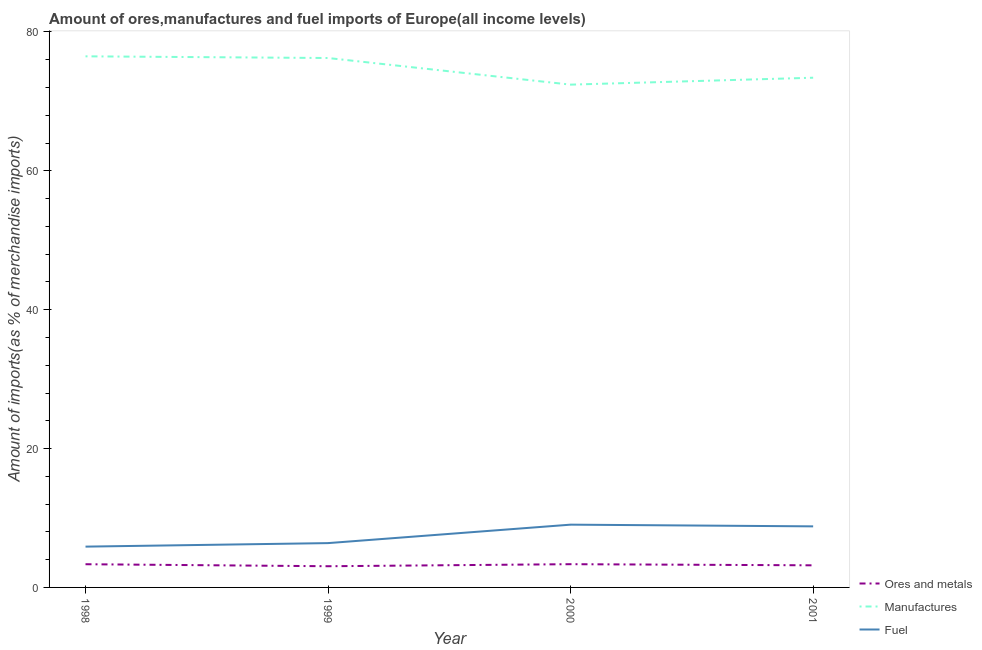How many different coloured lines are there?
Provide a short and direct response. 3. Is the number of lines equal to the number of legend labels?
Offer a very short reply. Yes. What is the percentage of fuel imports in 2000?
Your response must be concise. 9.04. Across all years, what is the maximum percentage of ores and metals imports?
Offer a very short reply. 3.35. Across all years, what is the minimum percentage of manufactures imports?
Your answer should be compact. 72.42. What is the total percentage of ores and metals imports in the graph?
Ensure brevity in your answer.  12.93. What is the difference between the percentage of manufactures imports in 1998 and that in 2001?
Offer a terse response. 3.08. What is the difference between the percentage of manufactures imports in 1999 and the percentage of fuel imports in 2001?
Offer a very short reply. 67.45. What is the average percentage of fuel imports per year?
Your answer should be very brief. 7.52. In the year 1999, what is the difference between the percentage of fuel imports and percentage of manufactures imports?
Your response must be concise. -69.87. In how many years, is the percentage of ores and metals imports greater than 44 %?
Your answer should be very brief. 0. What is the ratio of the percentage of ores and metals imports in 2000 to that in 2001?
Your answer should be compact. 1.05. Is the percentage of ores and metals imports in 1998 less than that in 2000?
Keep it short and to the point. Yes. Is the difference between the percentage of manufactures imports in 1998 and 2001 greater than the difference between the percentage of ores and metals imports in 1998 and 2001?
Give a very brief answer. Yes. What is the difference between the highest and the second highest percentage of manufactures imports?
Offer a very short reply. 0.24. What is the difference between the highest and the lowest percentage of ores and metals imports?
Give a very brief answer. 0.29. How many lines are there?
Your response must be concise. 3. Are the values on the major ticks of Y-axis written in scientific E-notation?
Offer a terse response. No. Does the graph contain grids?
Offer a very short reply. No. Where does the legend appear in the graph?
Your response must be concise. Bottom right. How are the legend labels stacked?
Your answer should be very brief. Vertical. What is the title of the graph?
Provide a short and direct response. Amount of ores,manufactures and fuel imports of Europe(all income levels). What is the label or title of the X-axis?
Your answer should be very brief. Year. What is the label or title of the Y-axis?
Ensure brevity in your answer.  Amount of imports(as % of merchandise imports). What is the Amount of imports(as % of merchandise imports) of Ores and metals in 1998?
Make the answer very short. 3.34. What is the Amount of imports(as % of merchandise imports) of Manufactures in 1998?
Offer a very short reply. 76.49. What is the Amount of imports(as % of merchandise imports) of Fuel in 1998?
Provide a succinct answer. 5.88. What is the Amount of imports(as % of merchandise imports) in Ores and metals in 1999?
Your answer should be compact. 3.05. What is the Amount of imports(as % of merchandise imports) of Manufactures in 1999?
Your answer should be compact. 76.25. What is the Amount of imports(as % of merchandise imports) in Fuel in 1999?
Keep it short and to the point. 6.38. What is the Amount of imports(as % of merchandise imports) in Ores and metals in 2000?
Ensure brevity in your answer.  3.35. What is the Amount of imports(as % of merchandise imports) of Manufactures in 2000?
Ensure brevity in your answer.  72.42. What is the Amount of imports(as % of merchandise imports) in Fuel in 2000?
Give a very brief answer. 9.04. What is the Amount of imports(as % of merchandise imports) of Ores and metals in 2001?
Provide a short and direct response. 3.18. What is the Amount of imports(as % of merchandise imports) of Manufactures in 2001?
Your response must be concise. 73.41. What is the Amount of imports(as % of merchandise imports) in Fuel in 2001?
Make the answer very short. 8.8. Across all years, what is the maximum Amount of imports(as % of merchandise imports) of Ores and metals?
Make the answer very short. 3.35. Across all years, what is the maximum Amount of imports(as % of merchandise imports) of Manufactures?
Offer a terse response. 76.49. Across all years, what is the maximum Amount of imports(as % of merchandise imports) in Fuel?
Make the answer very short. 9.04. Across all years, what is the minimum Amount of imports(as % of merchandise imports) of Ores and metals?
Offer a terse response. 3.05. Across all years, what is the minimum Amount of imports(as % of merchandise imports) of Manufactures?
Provide a succinct answer. 72.42. Across all years, what is the minimum Amount of imports(as % of merchandise imports) of Fuel?
Make the answer very short. 5.88. What is the total Amount of imports(as % of merchandise imports) in Ores and metals in the graph?
Your response must be concise. 12.93. What is the total Amount of imports(as % of merchandise imports) in Manufactures in the graph?
Ensure brevity in your answer.  298.57. What is the total Amount of imports(as % of merchandise imports) in Fuel in the graph?
Your answer should be very brief. 30.1. What is the difference between the Amount of imports(as % of merchandise imports) in Ores and metals in 1998 and that in 1999?
Provide a short and direct response. 0.29. What is the difference between the Amount of imports(as % of merchandise imports) in Manufactures in 1998 and that in 1999?
Offer a very short reply. 0.24. What is the difference between the Amount of imports(as % of merchandise imports) in Fuel in 1998 and that in 1999?
Your answer should be compact. -0.51. What is the difference between the Amount of imports(as % of merchandise imports) in Ores and metals in 1998 and that in 2000?
Your answer should be compact. -0.01. What is the difference between the Amount of imports(as % of merchandise imports) of Manufactures in 1998 and that in 2000?
Make the answer very short. 4.08. What is the difference between the Amount of imports(as % of merchandise imports) of Fuel in 1998 and that in 2000?
Ensure brevity in your answer.  -3.16. What is the difference between the Amount of imports(as % of merchandise imports) of Ores and metals in 1998 and that in 2001?
Offer a very short reply. 0.16. What is the difference between the Amount of imports(as % of merchandise imports) of Manufactures in 1998 and that in 2001?
Your answer should be compact. 3.08. What is the difference between the Amount of imports(as % of merchandise imports) of Fuel in 1998 and that in 2001?
Your answer should be compact. -2.92. What is the difference between the Amount of imports(as % of merchandise imports) of Ores and metals in 1999 and that in 2000?
Your answer should be very brief. -0.29. What is the difference between the Amount of imports(as % of merchandise imports) of Manufactures in 1999 and that in 2000?
Your answer should be very brief. 3.83. What is the difference between the Amount of imports(as % of merchandise imports) in Fuel in 1999 and that in 2000?
Make the answer very short. -2.66. What is the difference between the Amount of imports(as % of merchandise imports) in Ores and metals in 1999 and that in 2001?
Offer a very short reply. -0.13. What is the difference between the Amount of imports(as % of merchandise imports) in Manufactures in 1999 and that in 2001?
Offer a terse response. 2.84. What is the difference between the Amount of imports(as % of merchandise imports) in Fuel in 1999 and that in 2001?
Ensure brevity in your answer.  -2.41. What is the difference between the Amount of imports(as % of merchandise imports) in Ores and metals in 2000 and that in 2001?
Keep it short and to the point. 0.16. What is the difference between the Amount of imports(as % of merchandise imports) of Manufactures in 2000 and that in 2001?
Keep it short and to the point. -1. What is the difference between the Amount of imports(as % of merchandise imports) in Fuel in 2000 and that in 2001?
Provide a short and direct response. 0.24. What is the difference between the Amount of imports(as % of merchandise imports) of Ores and metals in 1998 and the Amount of imports(as % of merchandise imports) of Manufactures in 1999?
Offer a very short reply. -72.91. What is the difference between the Amount of imports(as % of merchandise imports) of Ores and metals in 1998 and the Amount of imports(as % of merchandise imports) of Fuel in 1999?
Keep it short and to the point. -3.04. What is the difference between the Amount of imports(as % of merchandise imports) of Manufactures in 1998 and the Amount of imports(as % of merchandise imports) of Fuel in 1999?
Your answer should be compact. 70.11. What is the difference between the Amount of imports(as % of merchandise imports) in Ores and metals in 1998 and the Amount of imports(as % of merchandise imports) in Manufactures in 2000?
Give a very brief answer. -69.07. What is the difference between the Amount of imports(as % of merchandise imports) of Ores and metals in 1998 and the Amount of imports(as % of merchandise imports) of Fuel in 2000?
Offer a terse response. -5.7. What is the difference between the Amount of imports(as % of merchandise imports) in Manufactures in 1998 and the Amount of imports(as % of merchandise imports) in Fuel in 2000?
Keep it short and to the point. 67.45. What is the difference between the Amount of imports(as % of merchandise imports) of Ores and metals in 1998 and the Amount of imports(as % of merchandise imports) of Manufactures in 2001?
Make the answer very short. -70.07. What is the difference between the Amount of imports(as % of merchandise imports) in Ores and metals in 1998 and the Amount of imports(as % of merchandise imports) in Fuel in 2001?
Your answer should be compact. -5.45. What is the difference between the Amount of imports(as % of merchandise imports) in Manufactures in 1998 and the Amount of imports(as % of merchandise imports) in Fuel in 2001?
Your answer should be very brief. 67.7. What is the difference between the Amount of imports(as % of merchandise imports) in Ores and metals in 1999 and the Amount of imports(as % of merchandise imports) in Manufactures in 2000?
Your answer should be compact. -69.36. What is the difference between the Amount of imports(as % of merchandise imports) of Ores and metals in 1999 and the Amount of imports(as % of merchandise imports) of Fuel in 2000?
Give a very brief answer. -5.99. What is the difference between the Amount of imports(as % of merchandise imports) of Manufactures in 1999 and the Amount of imports(as % of merchandise imports) of Fuel in 2000?
Your response must be concise. 67.21. What is the difference between the Amount of imports(as % of merchandise imports) of Ores and metals in 1999 and the Amount of imports(as % of merchandise imports) of Manufactures in 2001?
Provide a short and direct response. -70.36. What is the difference between the Amount of imports(as % of merchandise imports) of Ores and metals in 1999 and the Amount of imports(as % of merchandise imports) of Fuel in 2001?
Offer a terse response. -5.74. What is the difference between the Amount of imports(as % of merchandise imports) of Manufactures in 1999 and the Amount of imports(as % of merchandise imports) of Fuel in 2001?
Keep it short and to the point. 67.45. What is the difference between the Amount of imports(as % of merchandise imports) in Ores and metals in 2000 and the Amount of imports(as % of merchandise imports) in Manufactures in 2001?
Offer a terse response. -70.07. What is the difference between the Amount of imports(as % of merchandise imports) of Ores and metals in 2000 and the Amount of imports(as % of merchandise imports) of Fuel in 2001?
Ensure brevity in your answer.  -5.45. What is the difference between the Amount of imports(as % of merchandise imports) in Manufactures in 2000 and the Amount of imports(as % of merchandise imports) in Fuel in 2001?
Ensure brevity in your answer.  63.62. What is the average Amount of imports(as % of merchandise imports) of Ores and metals per year?
Make the answer very short. 3.23. What is the average Amount of imports(as % of merchandise imports) of Manufactures per year?
Your answer should be very brief. 74.64. What is the average Amount of imports(as % of merchandise imports) of Fuel per year?
Offer a very short reply. 7.52. In the year 1998, what is the difference between the Amount of imports(as % of merchandise imports) in Ores and metals and Amount of imports(as % of merchandise imports) in Manufactures?
Keep it short and to the point. -73.15. In the year 1998, what is the difference between the Amount of imports(as % of merchandise imports) in Ores and metals and Amount of imports(as % of merchandise imports) in Fuel?
Your response must be concise. -2.54. In the year 1998, what is the difference between the Amount of imports(as % of merchandise imports) in Manufactures and Amount of imports(as % of merchandise imports) in Fuel?
Ensure brevity in your answer.  70.62. In the year 1999, what is the difference between the Amount of imports(as % of merchandise imports) of Ores and metals and Amount of imports(as % of merchandise imports) of Manufactures?
Offer a very short reply. -73.2. In the year 1999, what is the difference between the Amount of imports(as % of merchandise imports) in Ores and metals and Amount of imports(as % of merchandise imports) in Fuel?
Offer a very short reply. -3.33. In the year 1999, what is the difference between the Amount of imports(as % of merchandise imports) in Manufactures and Amount of imports(as % of merchandise imports) in Fuel?
Ensure brevity in your answer.  69.87. In the year 2000, what is the difference between the Amount of imports(as % of merchandise imports) of Ores and metals and Amount of imports(as % of merchandise imports) of Manufactures?
Offer a terse response. -69.07. In the year 2000, what is the difference between the Amount of imports(as % of merchandise imports) of Ores and metals and Amount of imports(as % of merchandise imports) of Fuel?
Keep it short and to the point. -5.69. In the year 2000, what is the difference between the Amount of imports(as % of merchandise imports) of Manufactures and Amount of imports(as % of merchandise imports) of Fuel?
Ensure brevity in your answer.  63.38. In the year 2001, what is the difference between the Amount of imports(as % of merchandise imports) of Ores and metals and Amount of imports(as % of merchandise imports) of Manufactures?
Offer a terse response. -70.23. In the year 2001, what is the difference between the Amount of imports(as % of merchandise imports) in Ores and metals and Amount of imports(as % of merchandise imports) in Fuel?
Ensure brevity in your answer.  -5.61. In the year 2001, what is the difference between the Amount of imports(as % of merchandise imports) in Manufactures and Amount of imports(as % of merchandise imports) in Fuel?
Ensure brevity in your answer.  64.62. What is the ratio of the Amount of imports(as % of merchandise imports) in Ores and metals in 1998 to that in 1999?
Give a very brief answer. 1.09. What is the ratio of the Amount of imports(as % of merchandise imports) in Manufactures in 1998 to that in 1999?
Make the answer very short. 1. What is the ratio of the Amount of imports(as % of merchandise imports) of Fuel in 1998 to that in 1999?
Offer a very short reply. 0.92. What is the ratio of the Amount of imports(as % of merchandise imports) in Manufactures in 1998 to that in 2000?
Provide a succinct answer. 1.06. What is the ratio of the Amount of imports(as % of merchandise imports) of Fuel in 1998 to that in 2000?
Give a very brief answer. 0.65. What is the ratio of the Amount of imports(as % of merchandise imports) of Ores and metals in 1998 to that in 2001?
Offer a terse response. 1.05. What is the ratio of the Amount of imports(as % of merchandise imports) in Manufactures in 1998 to that in 2001?
Offer a terse response. 1.04. What is the ratio of the Amount of imports(as % of merchandise imports) in Fuel in 1998 to that in 2001?
Your answer should be very brief. 0.67. What is the ratio of the Amount of imports(as % of merchandise imports) in Ores and metals in 1999 to that in 2000?
Your answer should be compact. 0.91. What is the ratio of the Amount of imports(as % of merchandise imports) in Manufactures in 1999 to that in 2000?
Ensure brevity in your answer.  1.05. What is the ratio of the Amount of imports(as % of merchandise imports) of Fuel in 1999 to that in 2000?
Ensure brevity in your answer.  0.71. What is the ratio of the Amount of imports(as % of merchandise imports) of Ores and metals in 1999 to that in 2001?
Make the answer very short. 0.96. What is the ratio of the Amount of imports(as % of merchandise imports) in Manufactures in 1999 to that in 2001?
Ensure brevity in your answer.  1.04. What is the ratio of the Amount of imports(as % of merchandise imports) of Fuel in 1999 to that in 2001?
Provide a short and direct response. 0.73. What is the ratio of the Amount of imports(as % of merchandise imports) in Ores and metals in 2000 to that in 2001?
Your answer should be very brief. 1.05. What is the ratio of the Amount of imports(as % of merchandise imports) of Manufactures in 2000 to that in 2001?
Make the answer very short. 0.99. What is the ratio of the Amount of imports(as % of merchandise imports) in Fuel in 2000 to that in 2001?
Ensure brevity in your answer.  1.03. What is the difference between the highest and the second highest Amount of imports(as % of merchandise imports) in Ores and metals?
Your answer should be very brief. 0.01. What is the difference between the highest and the second highest Amount of imports(as % of merchandise imports) in Manufactures?
Ensure brevity in your answer.  0.24. What is the difference between the highest and the second highest Amount of imports(as % of merchandise imports) in Fuel?
Your answer should be very brief. 0.24. What is the difference between the highest and the lowest Amount of imports(as % of merchandise imports) of Ores and metals?
Provide a short and direct response. 0.29. What is the difference between the highest and the lowest Amount of imports(as % of merchandise imports) in Manufactures?
Offer a very short reply. 4.08. What is the difference between the highest and the lowest Amount of imports(as % of merchandise imports) of Fuel?
Offer a very short reply. 3.16. 